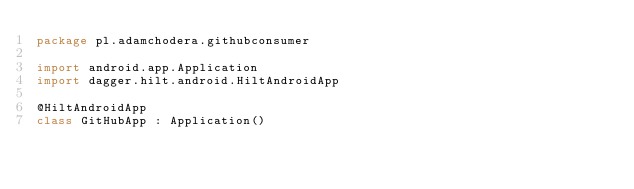<code> <loc_0><loc_0><loc_500><loc_500><_Kotlin_>package pl.adamchodera.githubconsumer

import android.app.Application
import dagger.hilt.android.HiltAndroidApp

@HiltAndroidApp
class GitHubApp : Application()
</code> 